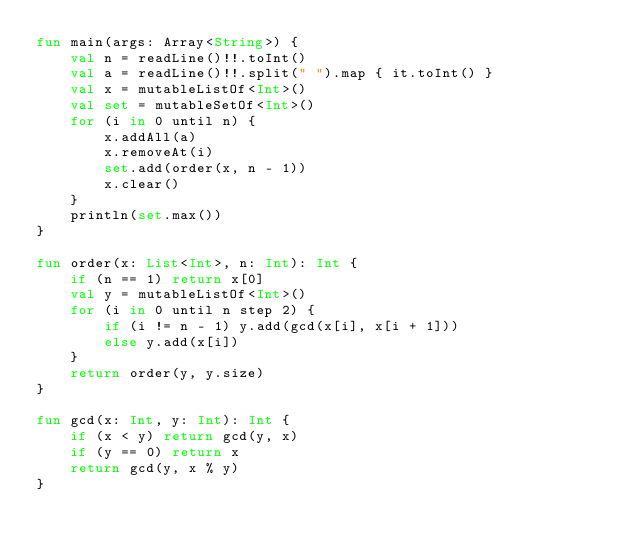Convert code to text. <code><loc_0><loc_0><loc_500><loc_500><_Kotlin_>fun main(args: Array<String>) {
    val n = readLine()!!.toInt()
    val a = readLine()!!.split(" ").map { it.toInt() }
    val x = mutableListOf<Int>()
    val set = mutableSetOf<Int>()
    for (i in 0 until n) {
        x.addAll(a)
        x.removeAt(i)
        set.add(order(x, n - 1))
        x.clear()
    }
    println(set.max())
}

fun order(x: List<Int>, n: Int): Int {
    if (n == 1) return x[0]
    val y = mutableListOf<Int>()
    for (i in 0 until n step 2) {
        if (i != n - 1) y.add(gcd(x[i], x[i + 1]))
        else y.add(x[i])
    }
    return order(y, y.size)
}

fun gcd(x: Int, y: Int): Int {
    if (x < y) return gcd(y, x)
    if (y == 0) return x
    return gcd(y, x % y)
}
</code> 